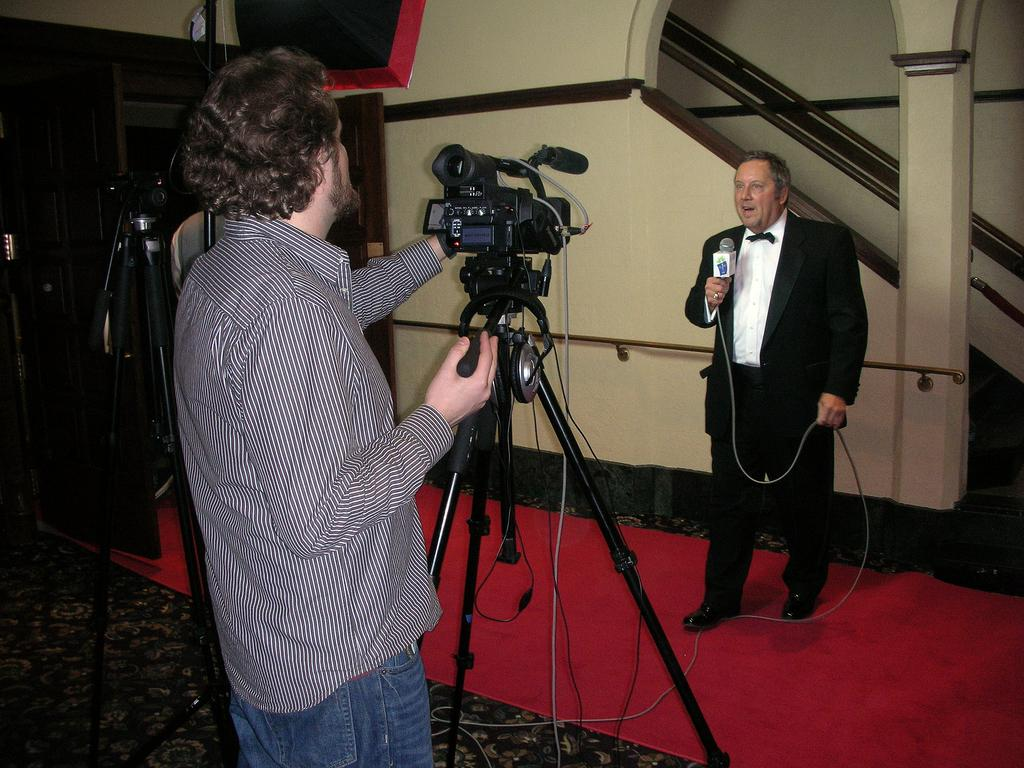What is the man in the image holding? The man is holding a camera in the image. How is the camera being held by the man? The man is holding the camera in his hand. What is happening in front of the camera? There is a man standing in front of the camera, and he is speaking. What is the man in front of the camera using to amplify his voice? The man in front of the camera is using a microphone. What type of account does the man in front of the camera have with the coal industry? There is no mention of an account or the coal industry in the image, so this question cannot be answered definitively. 